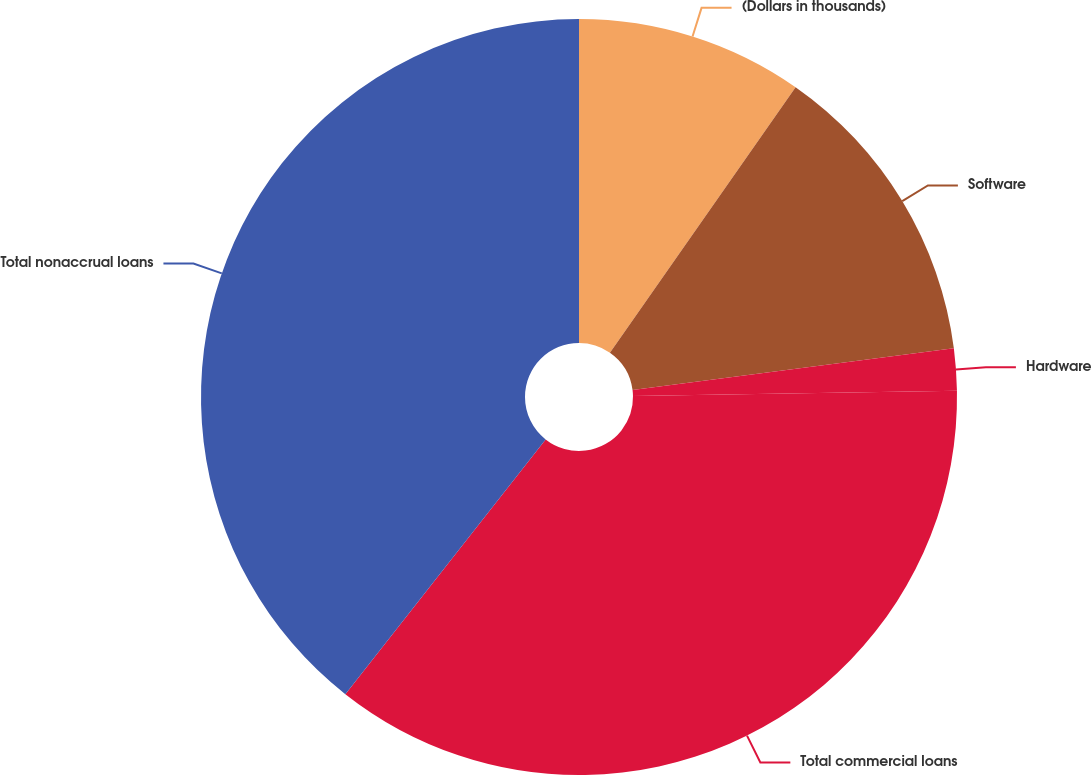Convert chart to OTSL. <chart><loc_0><loc_0><loc_500><loc_500><pie_chart><fcel>(Dollars in thousands)<fcel>Software<fcel>Hardware<fcel>Total commercial loans<fcel>Total nonaccrual loans<nl><fcel>9.71%<fcel>13.23%<fcel>1.79%<fcel>35.87%<fcel>39.39%<nl></chart> 